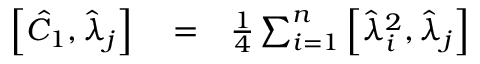Convert formula to latex. <formula><loc_0><loc_0><loc_500><loc_500>\begin{array} { r l r } { \left [ \hat { C } _ { 1 } , \hat { \lambda } _ { j } \right ] } & = } & { \frac { 1 } { 4 } \sum _ { i = 1 } ^ { n } \left [ \hat { \lambda } _ { i } ^ { 2 } , \hat { \lambda } _ { j } \right ] } \end{array}</formula> 